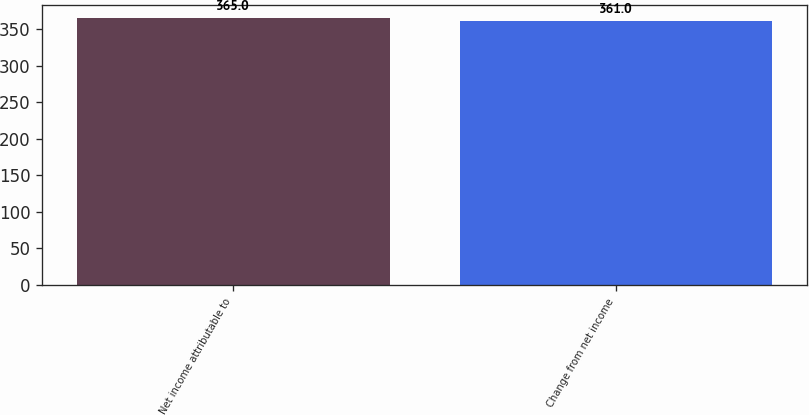<chart> <loc_0><loc_0><loc_500><loc_500><bar_chart><fcel>Net income attributable to<fcel>Change from net income<nl><fcel>365<fcel>361<nl></chart> 